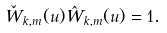<formula> <loc_0><loc_0><loc_500><loc_500>\check { W } _ { k , m } ( u ) \hat { W } _ { k , m } ( u ) = 1 .</formula> 